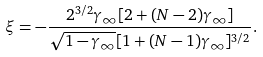<formula> <loc_0><loc_0><loc_500><loc_500>\xi = - \frac { 2 ^ { 3 / 2 } \gamma _ { \infty } [ 2 + ( N - 2 ) \gamma _ { \infty } ] } { \sqrt { 1 - \gamma _ { \infty } } [ 1 + ( N - 1 ) \gamma _ { \infty } ] ^ { 3 / 2 } } .</formula> 